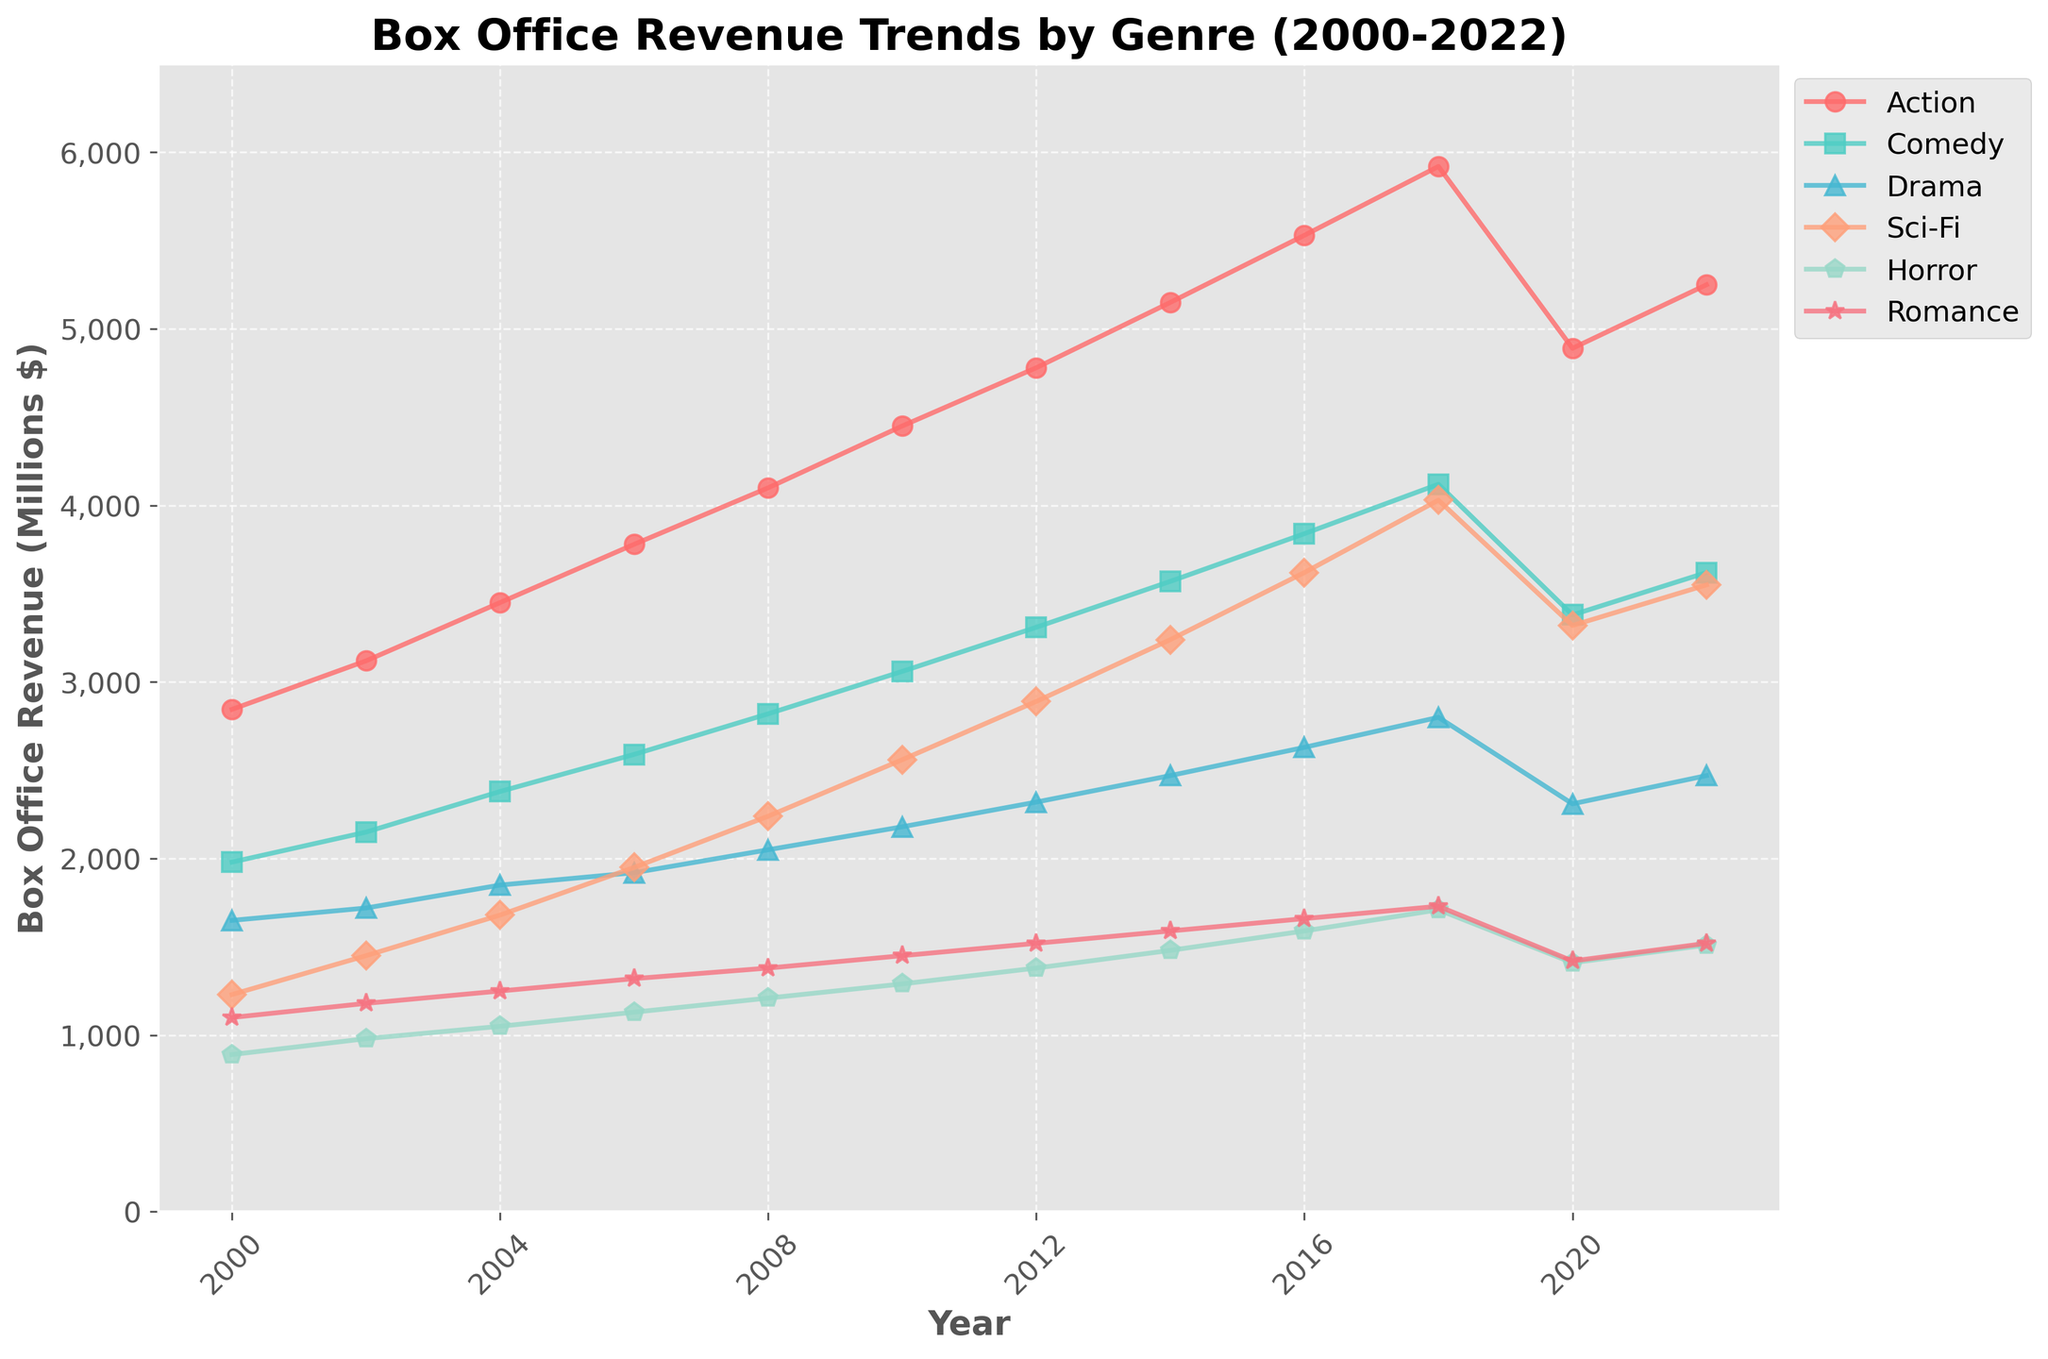Which genre experienced the largest increase in box office revenue from 2000 to 2022? To determine the largest increase, subtract the 2000 revenue from the 2022 revenue for each genre. Action: 5250-2845 = 2405, Comedy: 3620-1980 = 1640, Drama: 2470-1650 = 820, Sci-Fi: 3550-1230 = 2320, Horror: 1510-890 = 620, Romance: 1520-1100 = 420. The Action genre has the largest increase with 2405 millions.
Answer: Action Which year did Sci-Fi surpass 3000 million in box office revenue? Look at the value sequence for Sci-Fi and identify the first year where the revenue is more than 3000. Sci-Fi first surpasses 3000 at 3240 in 2014.
Answer: 2014 Did Horror ever earn more than 2000 million in any year? Check the values for Horror from 2000 to 2022. The highest point is 1710 in 2018, which is below 2000.
Answer: No Which genres experienced a decrease in revenue between 2018 and 2020? Compare the revenue for each genre between 2018 and 2020. Action: 5920 > 4890, Comedy: 4120 > 3380, Drama: 2800 > 2310, Sci-Fi: 4030 > 3320, Horror: 1710 > 1410, Romance: 1730 > 1420. All genres experienced a decrease.
Answer: All genres Which genre shows the most consistent growth trend from 2000 to 2018 based on visual observation? By looking at the smoothness and steadiness of the line, Action shows the most consistent growth over the given years without significant drops.
Answer: Action What is the combined box office revenue of Comedy and Drama in 2006? Add the values for Comedy and Drama in 2006. Comedy: 2590, Drama: 1920. Combined revenue: 2590 + 1920 = 4510 million.
Answer: 4510 Between 2014 to 2018, which genre had the highest average box office revenue? Find the average revenue for each genre between 2014 and 2018. Action: (5150+5530+5920)/3 = 5533.33, Comedy: (3570+3840+4120)/3 = 3843.33, Drama: (2470+2630+2800)/3 = 2633.33, Sci-Fi: (3240+3620+4030)/3 = 3630, Horror: (1480+1590+1710)/3 = 1593.33, Romance: (1590+1660+1730)/3 = 1660. Action had the highest average.
Answer: Action Which year saw the highest box office revenue for Romance films? Compare the Romance revenue values for each year. The highest value (1730) occurs in 2018.
Answer: 2018 What year did Drama surpass 2000 million in box office revenue for the first time? Check each year's Drama value and see when it first goes above 2000. Drama first surpasses 2000 in 2008 with 2050 million.
Answer: 2008 